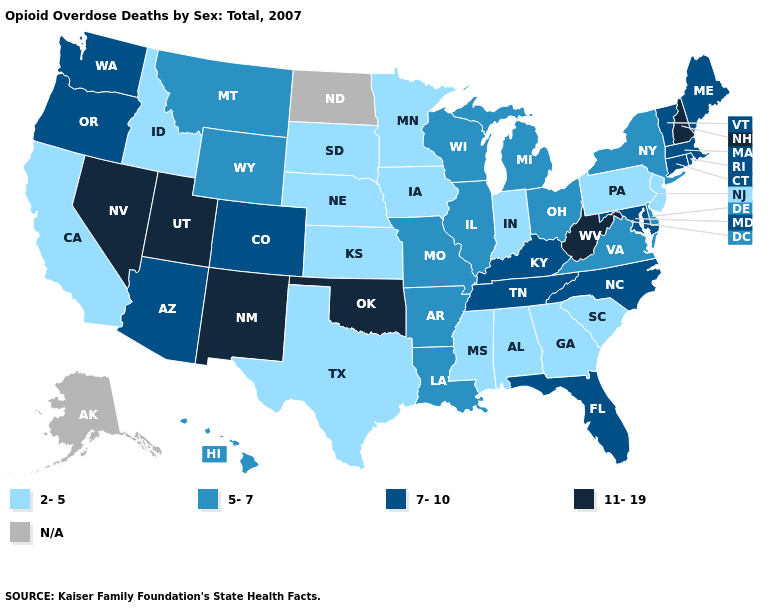Among the states that border Missouri , does Illinois have the lowest value?
Be succinct. No. What is the highest value in the USA?
Be succinct. 11-19. What is the value of California?
Short answer required. 2-5. Among the states that border Kansas , does Oklahoma have the highest value?
Give a very brief answer. Yes. Does the first symbol in the legend represent the smallest category?
Short answer required. Yes. Among the states that border Utah , which have the highest value?
Give a very brief answer. Nevada, New Mexico. Name the states that have a value in the range 2-5?
Write a very short answer. Alabama, California, Georgia, Idaho, Indiana, Iowa, Kansas, Minnesota, Mississippi, Nebraska, New Jersey, Pennsylvania, South Carolina, South Dakota, Texas. Name the states that have a value in the range N/A?
Write a very short answer. Alaska, North Dakota. What is the highest value in states that border Oregon?
Give a very brief answer. 11-19. What is the value of New Mexico?
Quick response, please. 11-19. Does Idaho have the lowest value in the West?
Answer briefly. Yes. What is the value of Wyoming?
Short answer required. 5-7. What is the lowest value in the USA?
Give a very brief answer. 2-5. Which states hav the highest value in the MidWest?
Keep it brief. Illinois, Michigan, Missouri, Ohio, Wisconsin. What is the value of Montana?
Quick response, please. 5-7. 